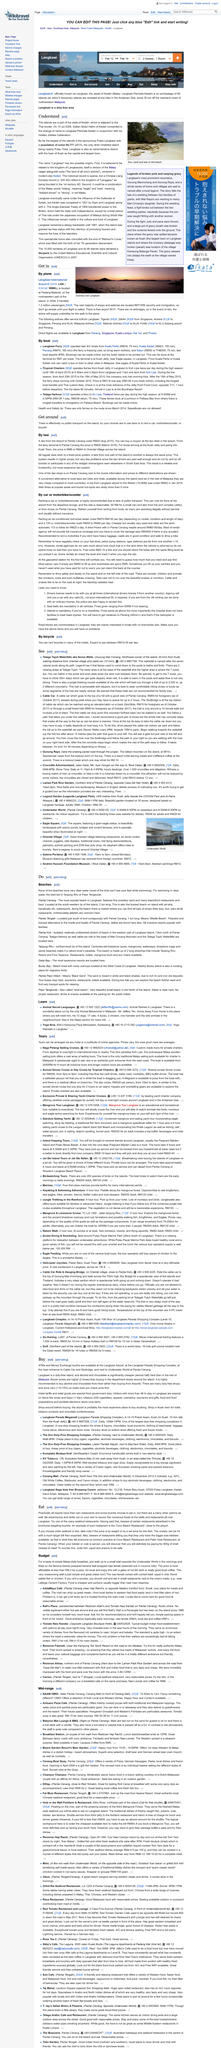List a handful of essential elements in this visual. Langkawi is an administrative district. What is the capital of Langkawi? It is Kuah. The largest island that is part of the state of Kedah is Pulau Langkawi. 